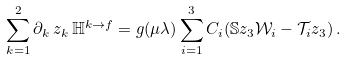Convert formula to latex. <formula><loc_0><loc_0><loc_500><loc_500>\sum _ { k = 1 } ^ { 2 } \partial _ { k } \, z _ { k } \, \mathbb { H } ^ { k \to f } = g ( \mu \lambda ) \sum _ { i = 1 } ^ { 3 } C _ { i } ( \mathbb { S } z _ { 3 } \mathcal { W } _ { i } - \mathcal { T } _ { i } z _ { 3 } ) \, .</formula> 